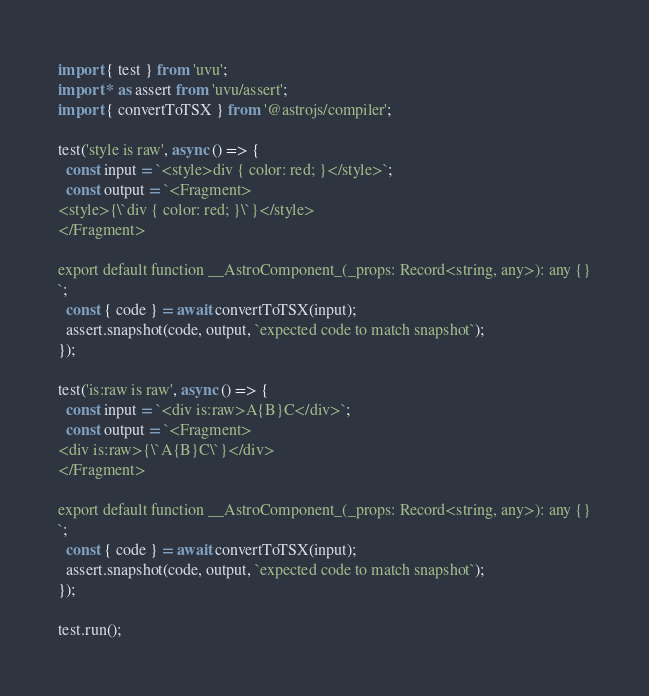Convert code to text. <code><loc_0><loc_0><loc_500><loc_500><_TypeScript_>import { test } from 'uvu';
import * as assert from 'uvu/assert';
import { convertToTSX } from '@astrojs/compiler';

test('style is raw', async () => {
  const input = `<style>div { color: red; }</style>`;
  const output = `<Fragment>
<style>{\`div { color: red; }\`}</style>
</Fragment>

export default function __AstroComponent_(_props: Record<string, any>): any {}
`;
  const { code } = await convertToTSX(input);
  assert.snapshot(code, output, `expected code to match snapshot`);
});

test('is:raw is raw', async () => {
  const input = `<div is:raw>A{B}C</div>`;
  const output = `<Fragment>
<div is:raw>{\`A{B}C\`}</div>
</Fragment>

export default function __AstroComponent_(_props: Record<string, any>): any {}
`;
  const { code } = await convertToTSX(input);
  assert.snapshot(code, output, `expected code to match snapshot`);
});

test.run();
</code> 